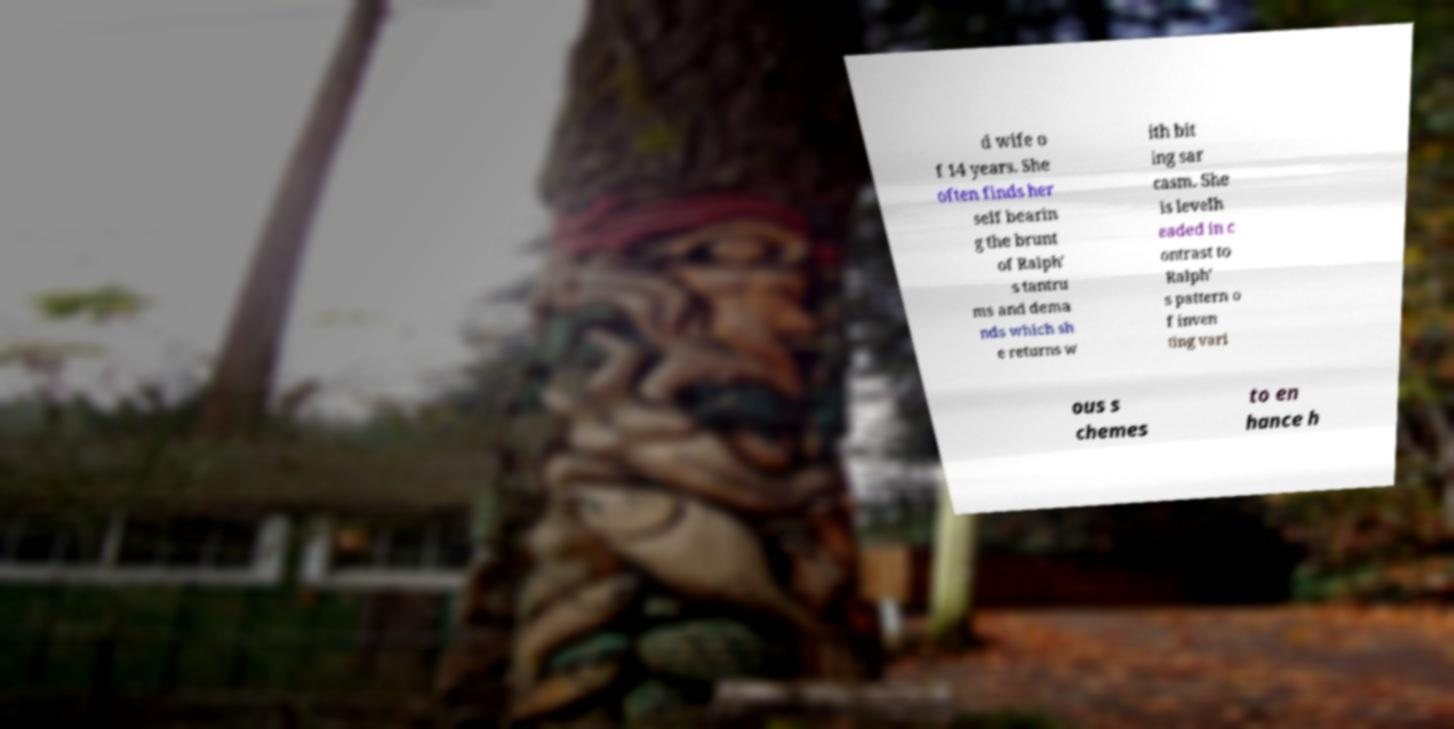Could you assist in decoding the text presented in this image and type it out clearly? d wife o f 14 years. She often finds her self bearin g the brunt of Ralph' s tantru ms and dema nds which sh e returns w ith bit ing sar casm. She is levelh eaded in c ontrast to Ralph' s pattern o f inven ting vari ous s chemes to en hance h 